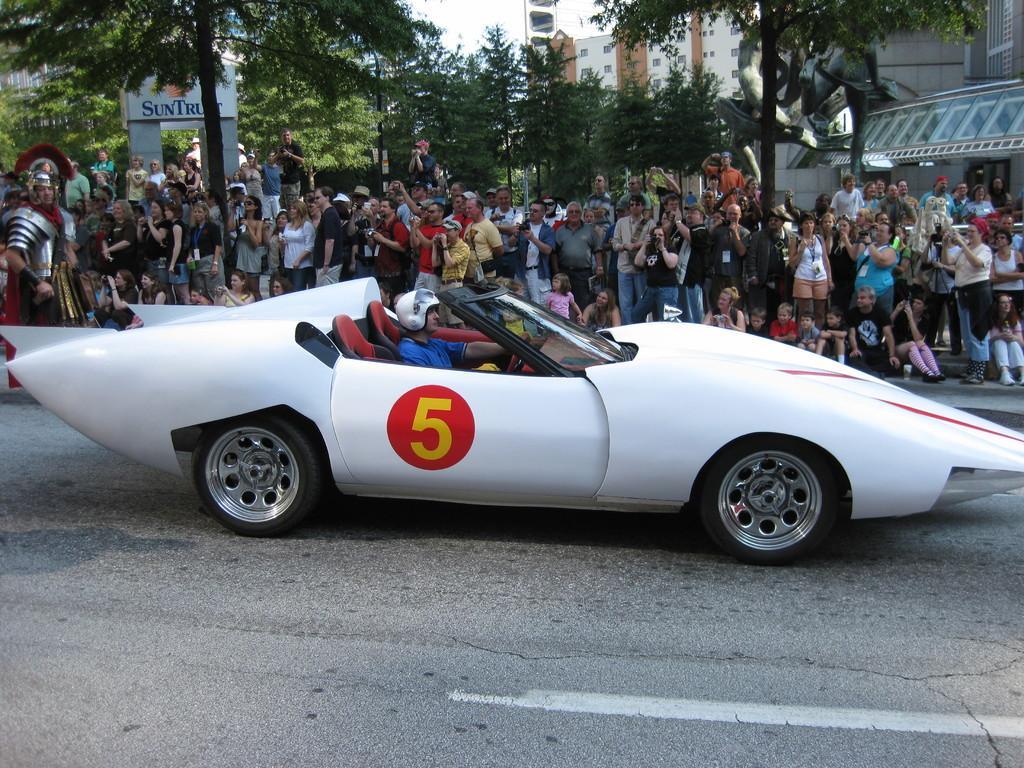Please provide a concise description of this image. In this image I see a white car and I see that there is a person sitting in the car and I see the road. In the background I see number of people, trees, buildings and the sky and I see a word written over here. 